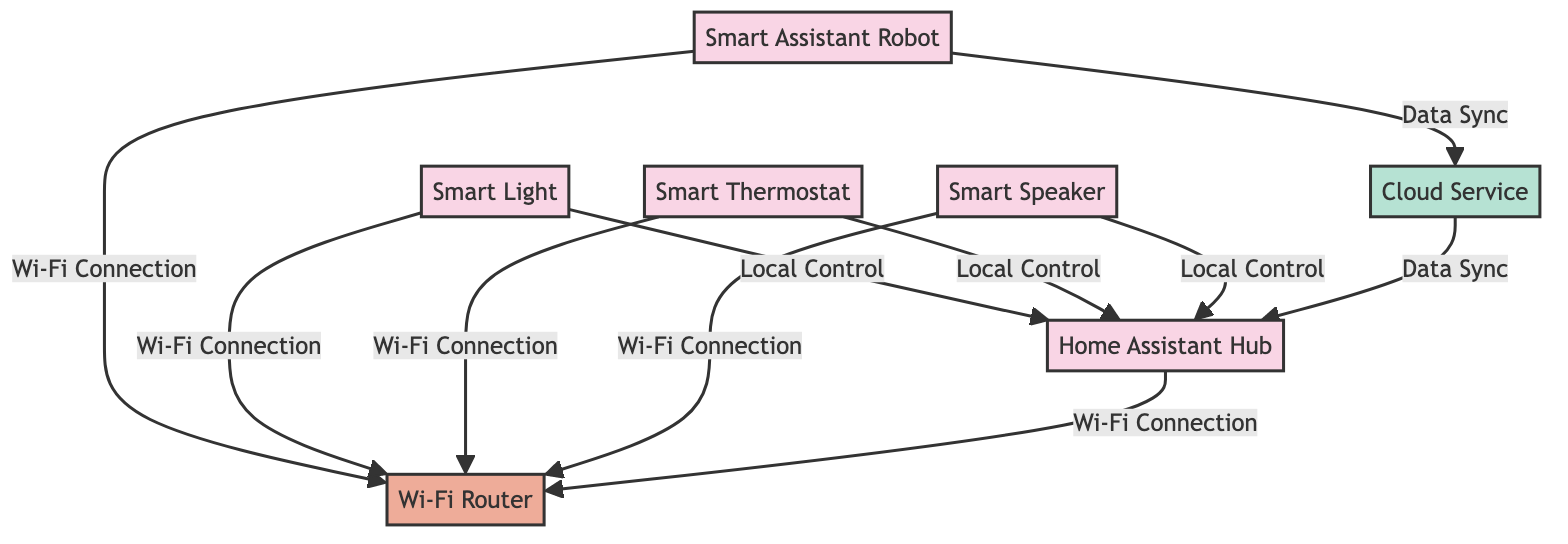What type of connection does the Smart Assistant Robot have to the Wi-Fi Router? The Smart Assistant Robot connects to the Wi-Fi Router via a Wi-Fi Connection, which can be seen in the edge connecting these two nodes in the diagram.
Answer: Wi-Fi Connection How many devices are connected to the Wi-Fi Router? In the diagram, there are four devices: the Smart Assistant Robot, Smart Light, Smart Thermostat, and Smart Speaker, all connected to the Wi-Fi Router. Counting these connections gives us a total of four.
Answer: 4 What is the relationship between the Smart Light and the Home Assistant Hub? The relationship is a Local Control connection, as indicated by the edge connecting the Smart Light node to the Home Assistant Hub node in the diagram.
Answer: Local Control Which cloud service is used by the Smart Assistant Robot? The diagram specifies a connection from the Smart Assistant Robot to a Cloud Service, indicating that it uses this service for functionality related to data signals.
Answer: Cloud Service What type of connections exist between the Cloud Service and the Home Assistant Hub? The connection between the Cloud Service and the Home Assistant Hub is characterized as a Data Sync, as clearly outlined by the edge connecting these two nodes in the diagram.
Answer: Data Sync Which device does not have a direct Wi-Fi connection to the Wi-Fi Router? The Home Assistant Hub does not connect directly to the Wi-Fi Router, but instead connects through Local Control relationships with the smart devices.
Answer: Home Assistant Hub If the Smart Assistant Robot loses its Wi-Fi connection, what devices would it still communicate with? The Smart Assistant Robot primarily syncs data with the Cloud Service and relies on Wi-Fi to connect with the Home Assistant Hub and other devices. Without Wi-Fi, it cannot connect to Home Assistant Hub, Smart Light, Smart Thermostat, or Smart Speaker, but it would still be able to sync with the Cloud Service if alternatives are available.
Answer: Cloud Service How many devices sync data with the Cloud Service? The diagram shows two connections related to data sync: one from the Smart Assistant Robot and one from the Home Assistant Hub, indicating that there are two devices syncing data with the Cloud Service.
Answer: 2 What connections use Local Control in the diagram? The connections using Local Control are indicated from the Smart Light, Smart Thermostat, and Smart Speaker to the Home Assistant Hub, thus illustrating three Local Control connections.
Answer: Smart Light, Smart Thermostat, Smart Speaker What are the types of nodes depicted in this communication network diagram? There are three types of nodes: devices (Smart Assistant Robot, Smart Light, Smart Thermostat, Smart Speaker, Home Assistant Hub), network (Wi-Fi Router), and cloud (Cloud Service).
Answer: Devices, Network, Cloud 